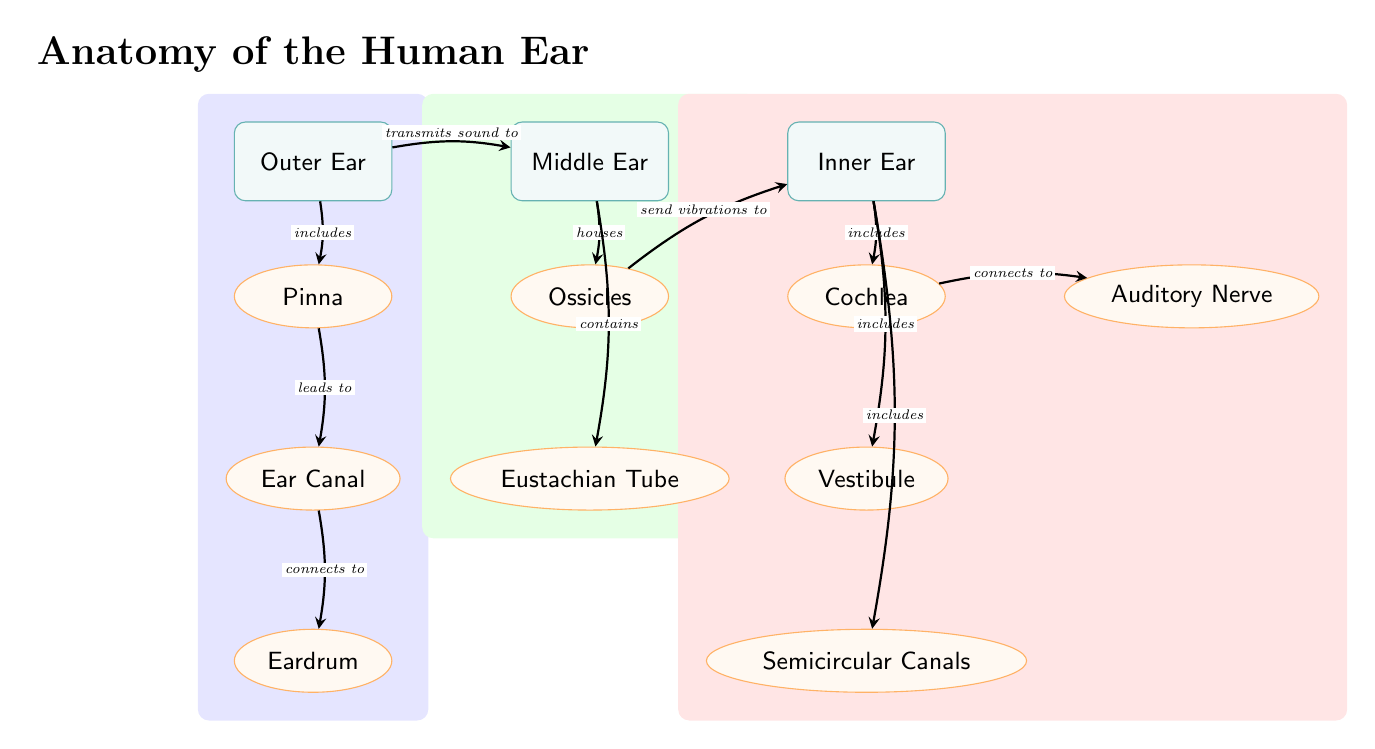What are the three main sections of the ear shown in the diagram? The diagram clearly labels the three main sections as Outer Ear, Middle Ear, and Inner Ear, which are presented sequentially from left to right.
Answer: Outer Ear, Middle Ear, Inner Ear Which part of the ear connects to the Eardrum? The Ear Canal is the section indicated in the diagram that connects to the Eardrum, as shown by the directional arrows and labels connecting these two components.
Answer: Ear Canal How many components are included in the Inner Ear? The diagram outlines three components in the Inner Ear section: Cochlea, Vestibule, and Semicircular Canals. Therefore, there are a total of three distinct components listed in this section.
Answer: Three What is the function of the Ossicles as indicated in the diagram? According to the relationships shown, the Ossicles are responsible for sending vibrations to the Inner Ear, clarifying their function in the auditory process and connectivity to the other components.
Answer: Send vibrations to Inner Ear Which component is connected to the Cochlea? The diagram shows an arrow connecting the Cochlea to the Auditory Nerve, indicating that the Cochlea connects to this component as part of the sound processing pathway.
Answer: Auditory Nerve What does the Eustachian Tube connect to? The diagram specifically labels the Eustachian Tube as a component that is contained within the Middle Ear, indicating that it connects to the rest of the components in the Middle Ear region without a direct connection shown to other parts.
Answer: Middle Ear How does sound travel through the Outer Ear to the Middle Ear? As shown in the diagram, sound travels from the Pinna to the Ear Canal, which then leads to the Eardrum, establishing a clear path from the Outer to the Middle Ear.
Answer: Pinna to Ear Canal to Eardrum What color highlights the components of the Middle Ear? The diagram highlights the Middle Ear components in green, which includes the Ossicles and Eustachian Tube, as indicated by the background color used for this section.
Answer: Green 